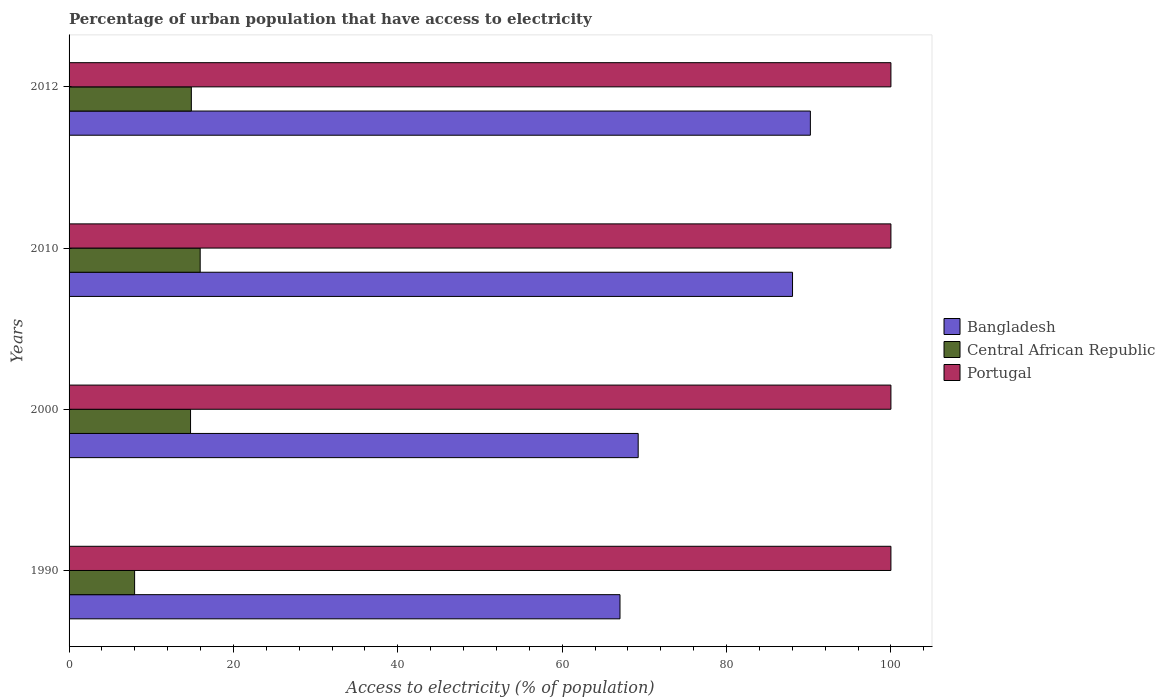How many groups of bars are there?
Offer a very short reply. 4. Are the number of bars per tick equal to the number of legend labels?
Provide a succinct answer. Yes. Are the number of bars on each tick of the Y-axis equal?
Make the answer very short. Yes. How many bars are there on the 4th tick from the top?
Offer a very short reply. 3. How many bars are there on the 2nd tick from the bottom?
Ensure brevity in your answer.  3. What is the label of the 1st group of bars from the top?
Offer a terse response. 2012. In how many cases, is the number of bars for a given year not equal to the number of legend labels?
Provide a short and direct response. 0. What is the percentage of urban population that have access to electricity in Central African Republic in 2000?
Keep it short and to the point. 14.78. Across all years, what is the maximum percentage of urban population that have access to electricity in Portugal?
Make the answer very short. 100. Across all years, what is the minimum percentage of urban population that have access to electricity in Portugal?
Offer a very short reply. 100. In which year was the percentage of urban population that have access to electricity in Central African Republic maximum?
Provide a short and direct response. 2010. What is the total percentage of urban population that have access to electricity in Central African Republic in the graph?
Provide a short and direct response. 53.59. What is the difference between the percentage of urban population that have access to electricity in Central African Republic in 2000 and that in 2010?
Ensure brevity in your answer.  -1.17. What is the difference between the percentage of urban population that have access to electricity in Central African Republic in 1990 and the percentage of urban population that have access to electricity in Bangladesh in 2010?
Provide a short and direct response. -80.05. What is the average percentage of urban population that have access to electricity in Bangladesh per year?
Provide a succinct answer. 78.63. In the year 2000, what is the difference between the percentage of urban population that have access to electricity in Central African Republic and percentage of urban population that have access to electricity in Portugal?
Offer a very short reply. -85.22. In how many years, is the percentage of urban population that have access to electricity in Central African Republic greater than 64 %?
Offer a terse response. 0. Is the percentage of urban population that have access to electricity in Central African Republic in 1990 less than that in 2010?
Your answer should be very brief. Yes. Is the difference between the percentage of urban population that have access to electricity in Central African Republic in 2010 and 2012 greater than the difference between the percentage of urban population that have access to electricity in Portugal in 2010 and 2012?
Your answer should be compact. Yes. What is the difference between the highest and the second highest percentage of urban population that have access to electricity in Bangladesh?
Ensure brevity in your answer.  2.17. What does the 3rd bar from the bottom in 2000 represents?
Your answer should be compact. Portugal. Is it the case that in every year, the sum of the percentage of urban population that have access to electricity in Portugal and percentage of urban population that have access to electricity in Bangladesh is greater than the percentage of urban population that have access to electricity in Central African Republic?
Offer a very short reply. Yes. Are all the bars in the graph horizontal?
Give a very brief answer. Yes. How many years are there in the graph?
Give a very brief answer. 4. Are the values on the major ticks of X-axis written in scientific E-notation?
Ensure brevity in your answer.  No. Does the graph contain any zero values?
Make the answer very short. No. Does the graph contain grids?
Your response must be concise. No. Where does the legend appear in the graph?
Keep it short and to the point. Center right. How many legend labels are there?
Your answer should be very brief. 3. How are the legend labels stacked?
Your answer should be very brief. Vertical. What is the title of the graph?
Give a very brief answer. Percentage of urban population that have access to electricity. What is the label or title of the X-axis?
Your answer should be compact. Access to electricity (% of population). What is the Access to electricity (% of population) of Bangladesh in 1990?
Your answer should be very brief. 67.04. What is the Access to electricity (% of population) of Central African Republic in 1990?
Ensure brevity in your answer.  7.98. What is the Access to electricity (% of population) of Bangladesh in 2000?
Ensure brevity in your answer.  69.25. What is the Access to electricity (% of population) in Central African Republic in 2000?
Ensure brevity in your answer.  14.78. What is the Access to electricity (% of population) in Portugal in 2000?
Provide a succinct answer. 100. What is the Access to electricity (% of population) of Bangladesh in 2010?
Provide a succinct answer. 88.03. What is the Access to electricity (% of population) of Central African Republic in 2010?
Provide a succinct answer. 15.95. What is the Access to electricity (% of population) of Bangladesh in 2012?
Make the answer very short. 90.2. What is the Access to electricity (% of population) of Central African Republic in 2012?
Your answer should be compact. 14.88. Across all years, what is the maximum Access to electricity (% of population) of Bangladesh?
Provide a short and direct response. 90.2. Across all years, what is the maximum Access to electricity (% of population) of Central African Republic?
Offer a very short reply. 15.95. Across all years, what is the maximum Access to electricity (% of population) of Portugal?
Offer a very short reply. 100. Across all years, what is the minimum Access to electricity (% of population) in Bangladesh?
Provide a succinct answer. 67.04. Across all years, what is the minimum Access to electricity (% of population) in Central African Republic?
Ensure brevity in your answer.  7.98. Across all years, what is the minimum Access to electricity (% of population) in Portugal?
Provide a succinct answer. 100. What is the total Access to electricity (% of population) in Bangladesh in the graph?
Your answer should be compact. 314.51. What is the total Access to electricity (% of population) of Central African Republic in the graph?
Give a very brief answer. 53.59. What is the total Access to electricity (% of population) in Portugal in the graph?
Make the answer very short. 400. What is the difference between the Access to electricity (% of population) of Bangladesh in 1990 and that in 2000?
Keep it short and to the point. -2.21. What is the difference between the Access to electricity (% of population) of Central African Republic in 1990 and that in 2000?
Give a very brief answer. -6.81. What is the difference between the Access to electricity (% of population) in Bangladesh in 1990 and that in 2010?
Your answer should be very brief. -20.99. What is the difference between the Access to electricity (% of population) of Central African Republic in 1990 and that in 2010?
Offer a terse response. -7.98. What is the difference between the Access to electricity (% of population) of Portugal in 1990 and that in 2010?
Provide a short and direct response. 0. What is the difference between the Access to electricity (% of population) of Bangladesh in 1990 and that in 2012?
Ensure brevity in your answer.  -23.16. What is the difference between the Access to electricity (% of population) of Central African Republic in 1990 and that in 2012?
Your answer should be very brief. -6.9. What is the difference between the Access to electricity (% of population) in Bangladesh in 2000 and that in 2010?
Ensure brevity in your answer.  -18.78. What is the difference between the Access to electricity (% of population) in Central African Republic in 2000 and that in 2010?
Offer a very short reply. -1.17. What is the difference between the Access to electricity (% of population) in Portugal in 2000 and that in 2010?
Offer a very short reply. 0. What is the difference between the Access to electricity (% of population) of Bangladesh in 2000 and that in 2012?
Provide a short and direct response. -20.95. What is the difference between the Access to electricity (% of population) in Central African Republic in 2000 and that in 2012?
Ensure brevity in your answer.  -0.1. What is the difference between the Access to electricity (% of population) of Bangladesh in 2010 and that in 2012?
Provide a succinct answer. -2.17. What is the difference between the Access to electricity (% of population) in Central African Republic in 2010 and that in 2012?
Offer a very short reply. 1.08. What is the difference between the Access to electricity (% of population) in Bangladesh in 1990 and the Access to electricity (% of population) in Central African Republic in 2000?
Offer a terse response. 52.25. What is the difference between the Access to electricity (% of population) in Bangladesh in 1990 and the Access to electricity (% of population) in Portugal in 2000?
Offer a terse response. -32.96. What is the difference between the Access to electricity (% of population) in Central African Republic in 1990 and the Access to electricity (% of population) in Portugal in 2000?
Offer a very short reply. -92.02. What is the difference between the Access to electricity (% of population) of Bangladesh in 1990 and the Access to electricity (% of population) of Central African Republic in 2010?
Offer a terse response. 51.08. What is the difference between the Access to electricity (% of population) of Bangladesh in 1990 and the Access to electricity (% of population) of Portugal in 2010?
Your answer should be compact. -32.96. What is the difference between the Access to electricity (% of population) in Central African Republic in 1990 and the Access to electricity (% of population) in Portugal in 2010?
Give a very brief answer. -92.02. What is the difference between the Access to electricity (% of population) in Bangladesh in 1990 and the Access to electricity (% of population) in Central African Republic in 2012?
Your answer should be compact. 52.16. What is the difference between the Access to electricity (% of population) of Bangladesh in 1990 and the Access to electricity (% of population) of Portugal in 2012?
Ensure brevity in your answer.  -32.96. What is the difference between the Access to electricity (% of population) of Central African Republic in 1990 and the Access to electricity (% of population) of Portugal in 2012?
Ensure brevity in your answer.  -92.02. What is the difference between the Access to electricity (% of population) in Bangladesh in 2000 and the Access to electricity (% of population) in Central African Republic in 2010?
Keep it short and to the point. 53.3. What is the difference between the Access to electricity (% of population) of Bangladesh in 2000 and the Access to electricity (% of population) of Portugal in 2010?
Provide a succinct answer. -30.75. What is the difference between the Access to electricity (% of population) in Central African Republic in 2000 and the Access to electricity (% of population) in Portugal in 2010?
Your response must be concise. -85.22. What is the difference between the Access to electricity (% of population) in Bangladesh in 2000 and the Access to electricity (% of population) in Central African Republic in 2012?
Provide a short and direct response. 54.37. What is the difference between the Access to electricity (% of population) of Bangladesh in 2000 and the Access to electricity (% of population) of Portugal in 2012?
Provide a short and direct response. -30.75. What is the difference between the Access to electricity (% of population) of Central African Republic in 2000 and the Access to electricity (% of population) of Portugal in 2012?
Your answer should be compact. -85.22. What is the difference between the Access to electricity (% of population) of Bangladesh in 2010 and the Access to electricity (% of population) of Central African Republic in 2012?
Your answer should be very brief. 73.15. What is the difference between the Access to electricity (% of population) of Bangladesh in 2010 and the Access to electricity (% of population) of Portugal in 2012?
Your answer should be very brief. -11.97. What is the difference between the Access to electricity (% of population) in Central African Republic in 2010 and the Access to electricity (% of population) in Portugal in 2012?
Your response must be concise. -84.05. What is the average Access to electricity (% of population) in Bangladesh per year?
Your answer should be compact. 78.63. What is the average Access to electricity (% of population) of Central African Republic per year?
Provide a succinct answer. 13.4. In the year 1990, what is the difference between the Access to electricity (% of population) in Bangladesh and Access to electricity (% of population) in Central African Republic?
Make the answer very short. 59.06. In the year 1990, what is the difference between the Access to electricity (% of population) of Bangladesh and Access to electricity (% of population) of Portugal?
Give a very brief answer. -32.96. In the year 1990, what is the difference between the Access to electricity (% of population) of Central African Republic and Access to electricity (% of population) of Portugal?
Your answer should be very brief. -92.02. In the year 2000, what is the difference between the Access to electricity (% of population) in Bangladesh and Access to electricity (% of population) in Central African Republic?
Your answer should be very brief. 54.47. In the year 2000, what is the difference between the Access to electricity (% of population) in Bangladesh and Access to electricity (% of population) in Portugal?
Provide a short and direct response. -30.75. In the year 2000, what is the difference between the Access to electricity (% of population) of Central African Republic and Access to electricity (% of population) of Portugal?
Provide a short and direct response. -85.22. In the year 2010, what is the difference between the Access to electricity (% of population) in Bangladesh and Access to electricity (% of population) in Central African Republic?
Make the answer very short. 72.08. In the year 2010, what is the difference between the Access to electricity (% of population) in Bangladesh and Access to electricity (% of population) in Portugal?
Offer a very short reply. -11.97. In the year 2010, what is the difference between the Access to electricity (% of population) in Central African Republic and Access to electricity (% of population) in Portugal?
Give a very brief answer. -84.05. In the year 2012, what is the difference between the Access to electricity (% of population) of Bangladesh and Access to electricity (% of population) of Central African Republic?
Ensure brevity in your answer.  75.32. In the year 2012, what is the difference between the Access to electricity (% of population) of Bangladesh and Access to electricity (% of population) of Portugal?
Make the answer very short. -9.8. In the year 2012, what is the difference between the Access to electricity (% of population) in Central African Republic and Access to electricity (% of population) in Portugal?
Give a very brief answer. -85.12. What is the ratio of the Access to electricity (% of population) in Bangladesh in 1990 to that in 2000?
Offer a very short reply. 0.97. What is the ratio of the Access to electricity (% of population) of Central African Republic in 1990 to that in 2000?
Provide a succinct answer. 0.54. What is the ratio of the Access to electricity (% of population) of Bangladesh in 1990 to that in 2010?
Offer a terse response. 0.76. What is the ratio of the Access to electricity (% of population) of Central African Republic in 1990 to that in 2010?
Make the answer very short. 0.5. What is the ratio of the Access to electricity (% of population) in Portugal in 1990 to that in 2010?
Give a very brief answer. 1. What is the ratio of the Access to electricity (% of population) of Bangladesh in 1990 to that in 2012?
Give a very brief answer. 0.74. What is the ratio of the Access to electricity (% of population) of Central African Republic in 1990 to that in 2012?
Your answer should be compact. 0.54. What is the ratio of the Access to electricity (% of population) of Portugal in 1990 to that in 2012?
Offer a very short reply. 1. What is the ratio of the Access to electricity (% of population) of Bangladesh in 2000 to that in 2010?
Your answer should be compact. 0.79. What is the ratio of the Access to electricity (% of population) in Central African Republic in 2000 to that in 2010?
Give a very brief answer. 0.93. What is the ratio of the Access to electricity (% of population) of Portugal in 2000 to that in 2010?
Your answer should be very brief. 1. What is the ratio of the Access to electricity (% of population) in Bangladesh in 2000 to that in 2012?
Offer a terse response. 0.77. What is the ratio of the Access to electricity (% of population) in Central African Republic in 2000 to that in 2012?
Give a very brief answer. 0.99. What is the ratio of the Access to electricity (% of population) of Portugal in 2000 to that in 2012?
Offer a very short reply. 1. What is the ratio of the Access to electricity (% of population) of Bangladesh in 2010 to that in 2012?
Keep it short and to the point. 0.98. What is the ratio of the Access to electricity (% of population) in Central African Republic in 2010 to that in 2012?
Offer a very short reply. 1.07. What is the ratio of the Access to electricity (% of population) in Portugal in 2010 to that in 2012?
Offer a terse response. 1. What is the difference between the highest and the second highest Access to electricity (% of population) of Bangladesh?
Offer a very short reply. 2.17. What is the difference between the highest and the second highest Access to electricity (% of population) of Central African Republic?
Your answer should be compact. 1.08. What is the difference between the highest and the lowest Access to electricity (% of population) of Bangladesh?
Offer a terse response. 23.16. What is the difference between the highest and the lowest Access to electricity (% of population) of Central African Republic?
Your answer should be very brief. 7.98. What is the difference between the highest and the lowest Access to electricity (% of population) of Portugal?
Make the answer very short. 0. 